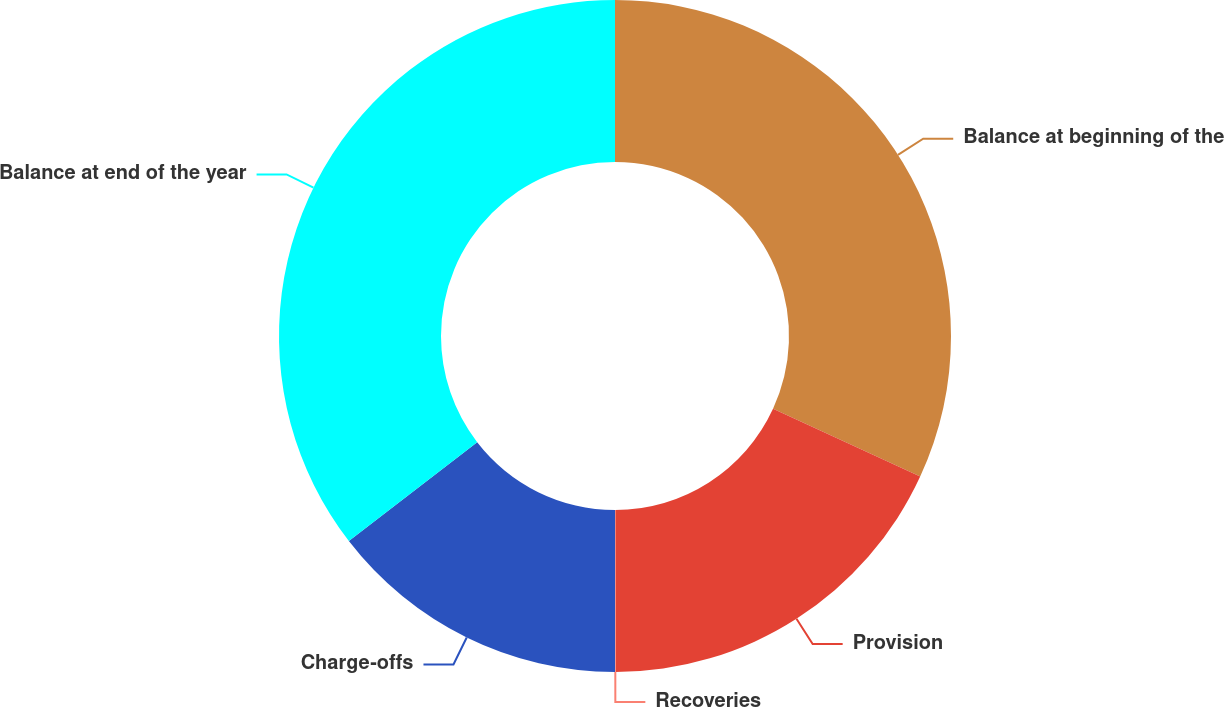Convert chart. <chart><loc_0><loc_0><loc_500><loc_500><pie_chart><fcel>Balance at beginning of the<fcel>Provision<fcel>Recoveries<fcel>Charge-offs<fcel>Balance at end of the year<nl><fcel>31.87%<fcel>18.1%<fcel>0.03%<fcel>14.55%<fcel>35.45%<nl></chart> 